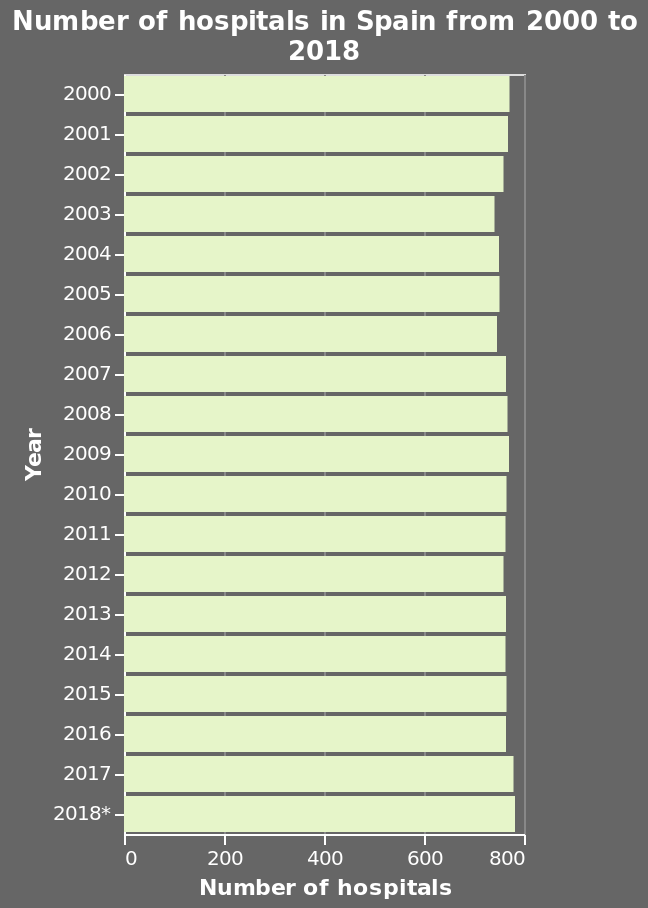<image>
Did the number of hospitals reach its peak in 2017 or 2018? Yes, the number of hospitals peaked in both 2017 and 2018. In which year did the number of hospitals in Spain reach its maximum? The number of hospitals in Spain reached its maximum in 2018. Was there a significant increase or decrease in the number of hospitals over the years?  No, there was very little variation in the number of hospitals between 2000 and 2018. Can we observe any significant changes in the number of hospitals over the years? No, there were no significant changes in the number of hospitals between 2000 and 2018. What is the minimum number of hospitals in Spain from 2000 to 2018? The minimum number of hospitals in Spain from 2000 to 2018 is 0. How many hospitals were there in Spain in 2012? The number of hospitals in Spain in 2012 is not provided in the description. Did the number of hospitals in Spain reach its maximum in 2019? No.The number of hospitals in Spain reached its maximum in 2018. 